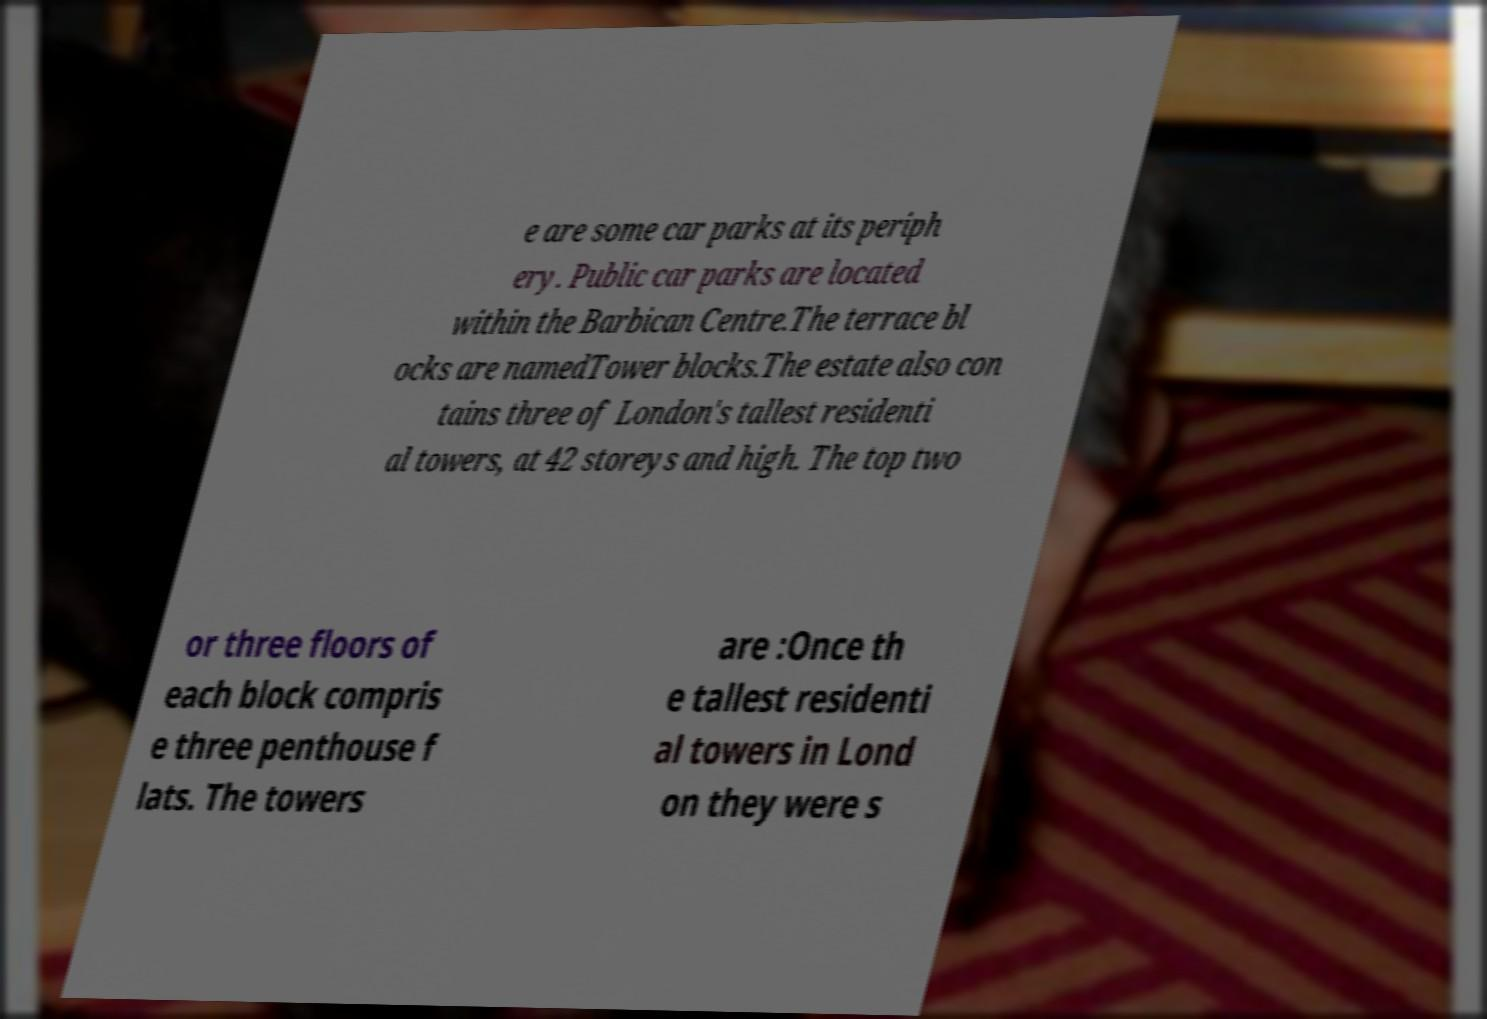Please identify and transcribe the text found in this image. e are some car parks at its periph ery. Public car parks are located within the Barbican Centre.The terrace bl ocks are namedTower blocks.The estate also con tains three of London's tallest residenti al towers, at 42 storeys and high. The top two or three floors of each block compris e three penthouse f lats. The towers are :Once th e tallest residenti al towers in Lond on they were s 